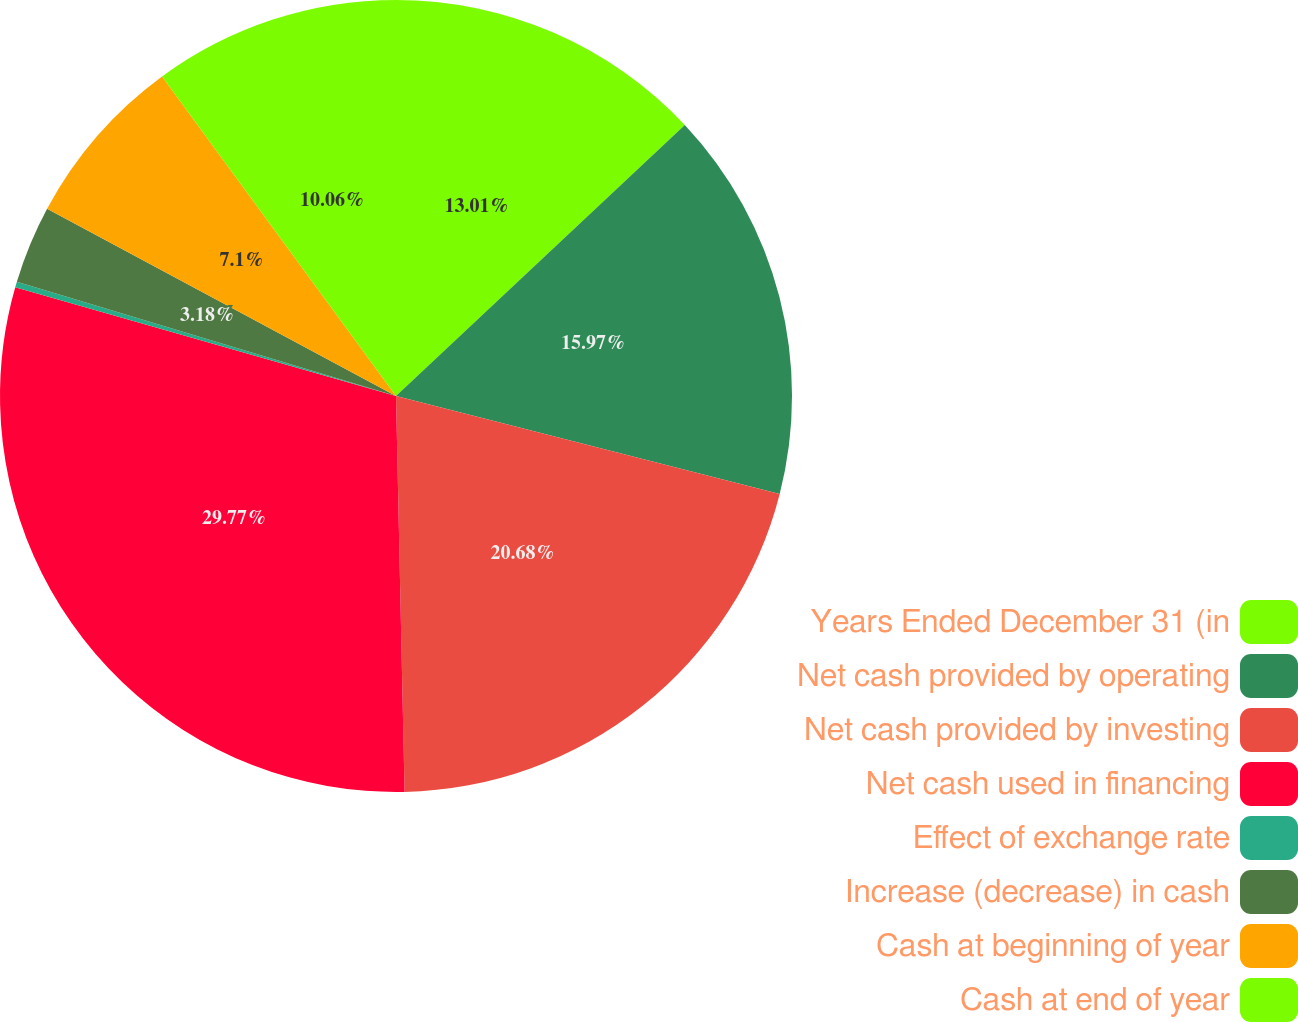Convert chart to OTSL. <chart><loc_0><loc_0><loc_500><loc_500><pie_chart><fcel>Years Ended December 31 (in<fcel>Net cash provided by operating<fcel>Net cash provided by investing<fcel>Net cash used in financing<fcel>Effect of exchange rate<fcel>Increase (decrease) in cash<fcel>Cash at beginning of year<fcel>Cash at end of year<nl><fcel>13.01%<fcel>15.97%<fcel>20.68%<fcel>29.78%<fcel>0.23%<fcel>3.18%<fcel>7.1%<fcel>10.06%<nl></chart> 